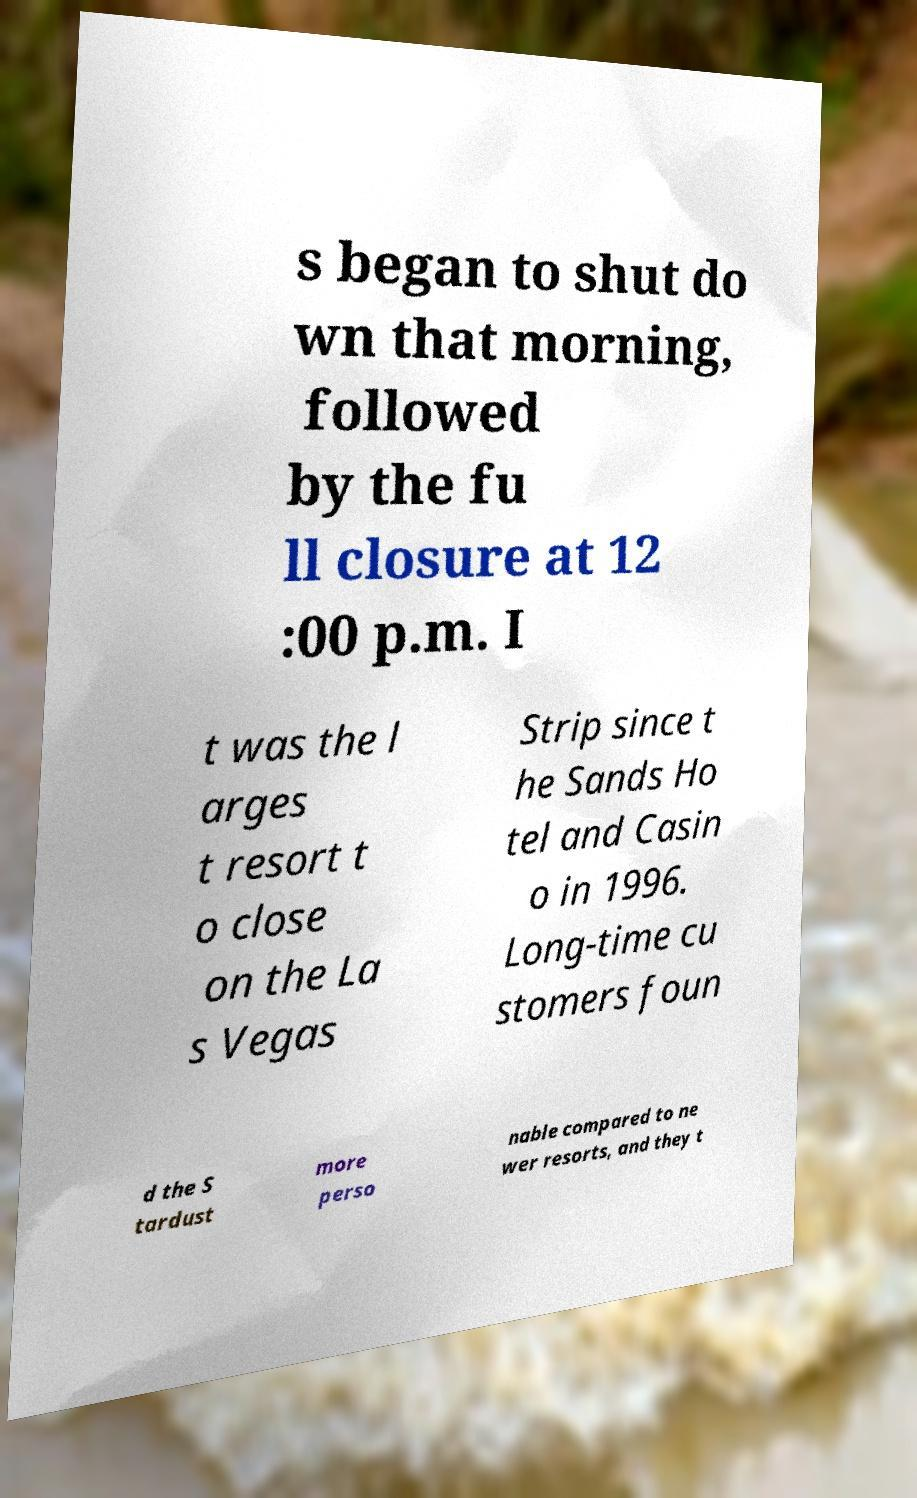Please read and relay the text visible in this image. What does it say? s began to shut do wn that morning, followed by the fu ll closure at 12 :00 p.m. I t was the l arges t resort t o close on the La s Vegas Strip since t he Sands Ho tel and Casin o in 1996. Long-time cu stomers foun d the S tardust more perso nable compared to ne wer resorts, and they t 